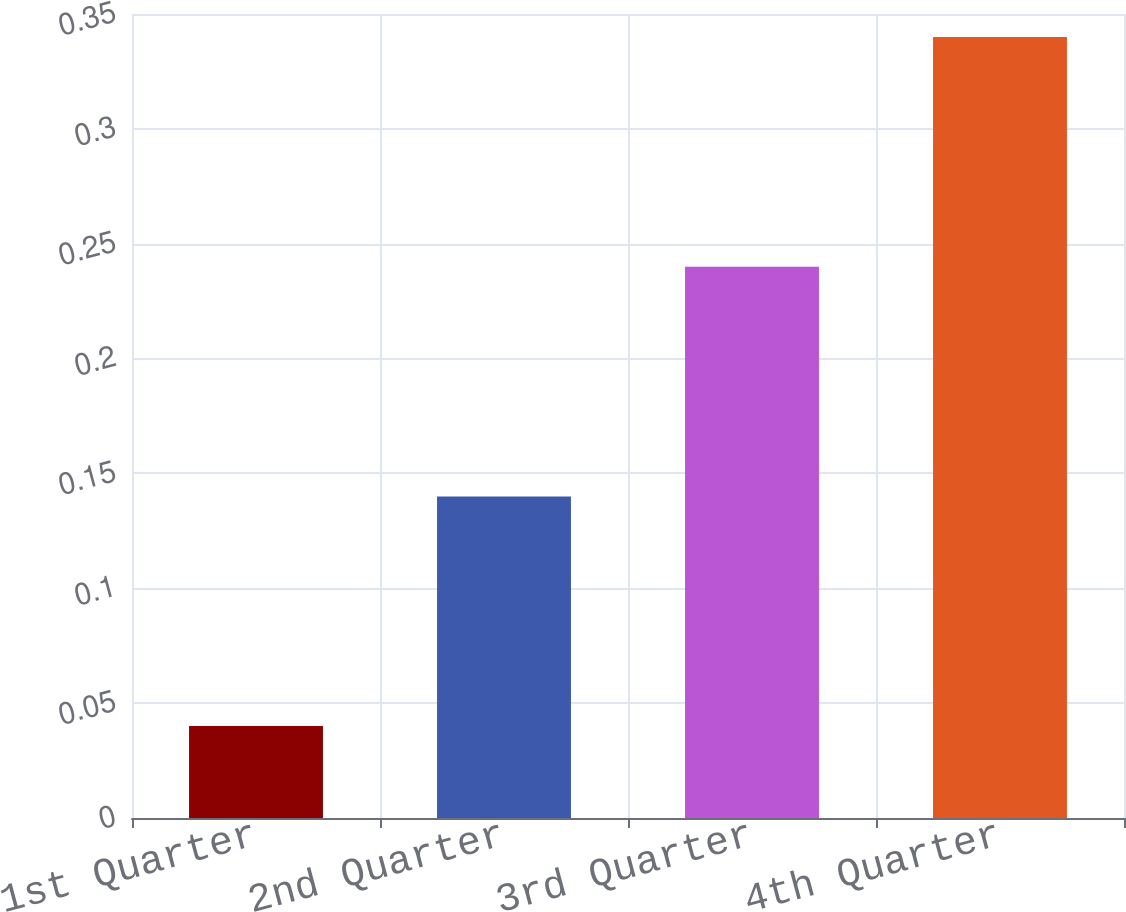Convert chart. <chart><loc_0><loc_0><loc_500><loc_500><bar_chart><fcel>1st Quarter<fcel>2nd Quarter<fcel>3rd Quarter<fcel>4th Quarter<nl><fcel>0.04<fcel>0.14<fcel>0.24<fcel>0.34<nl></chart> 